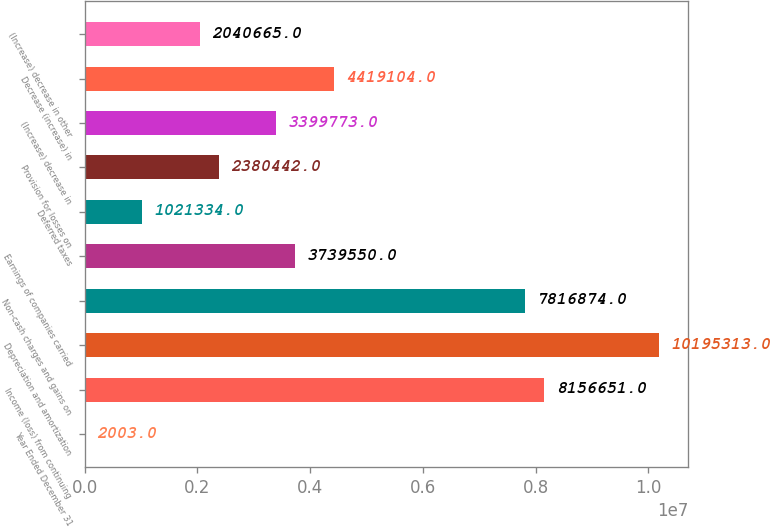<chart> <loc_0><loc_0><loc_500><loc_500><bar_chart><fcel>Year Ended December 31<fcel>Income (loss) from continuing<fcel>Depreciation and amortization<fcel>Non-cash charges and gains on<fcel>Earnings of companies carried<fcel>Deferred taxes<fcel>Provision for losses on<fcel>(Increase) decrease in<fcel>Decrease (increase) in<fcel>(Increase) decrease in other<nl><fcel>2003<fcel>8.15665e+06<fcel>1.01953e+07<fcel>7.81687e+06<fcel>3.73955e+06<fcel>1.02133e+06<fcel>2.38044e+06<fcel>3.39977e+06<fcel>4.4191e+06<fcel>2.04066e+06<nl></chart> 